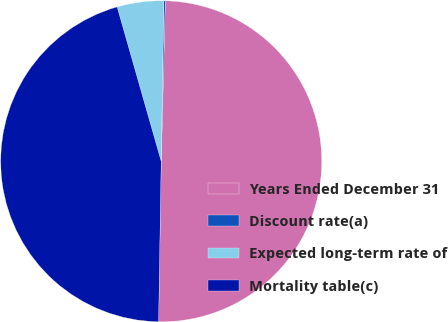Convert chart to OTSL. <chart><loc_0><loc_0><loc_500><loc_500><pie_chart><fcel>Years Ended December 31<fcel>Discount rate(a)<fcel>Expected long-term rate of<fcel>Mortality table(c)<nl><fcel>49.85%<fcel>0.15%<fcel>4.68%<fcel>45.32%<nl></chart> 